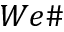Convert formula to latex. <formula><loc_0><loc_0><loc_500><loc_500>W e \#</formula> 